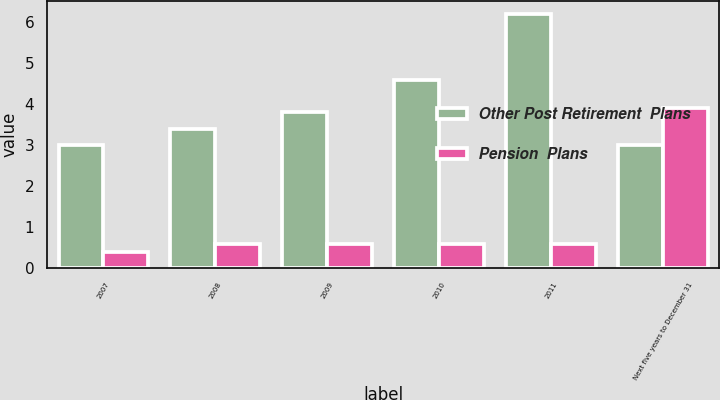<chart> <loc_0><loc_0><loc_500><loc_500><stacked_bar_chart><ecel><fcel>2007<fcel>2008<fcel>2009<fcel>2010<fcel>2011<fcel>Next five years to December 31<nl><fcel>Other Post Retirement  Plans<fcel>3<fcel>3.4<fcel>3.8<fcel>4.6<fcel>6.2<fcel>3<nl><fcel>Pension  Plans<fcel>0.4<fcel>0.6<fcel>0.6<fcel>0.6<fcel>0.6<fcel>3.9<nl></chart> 